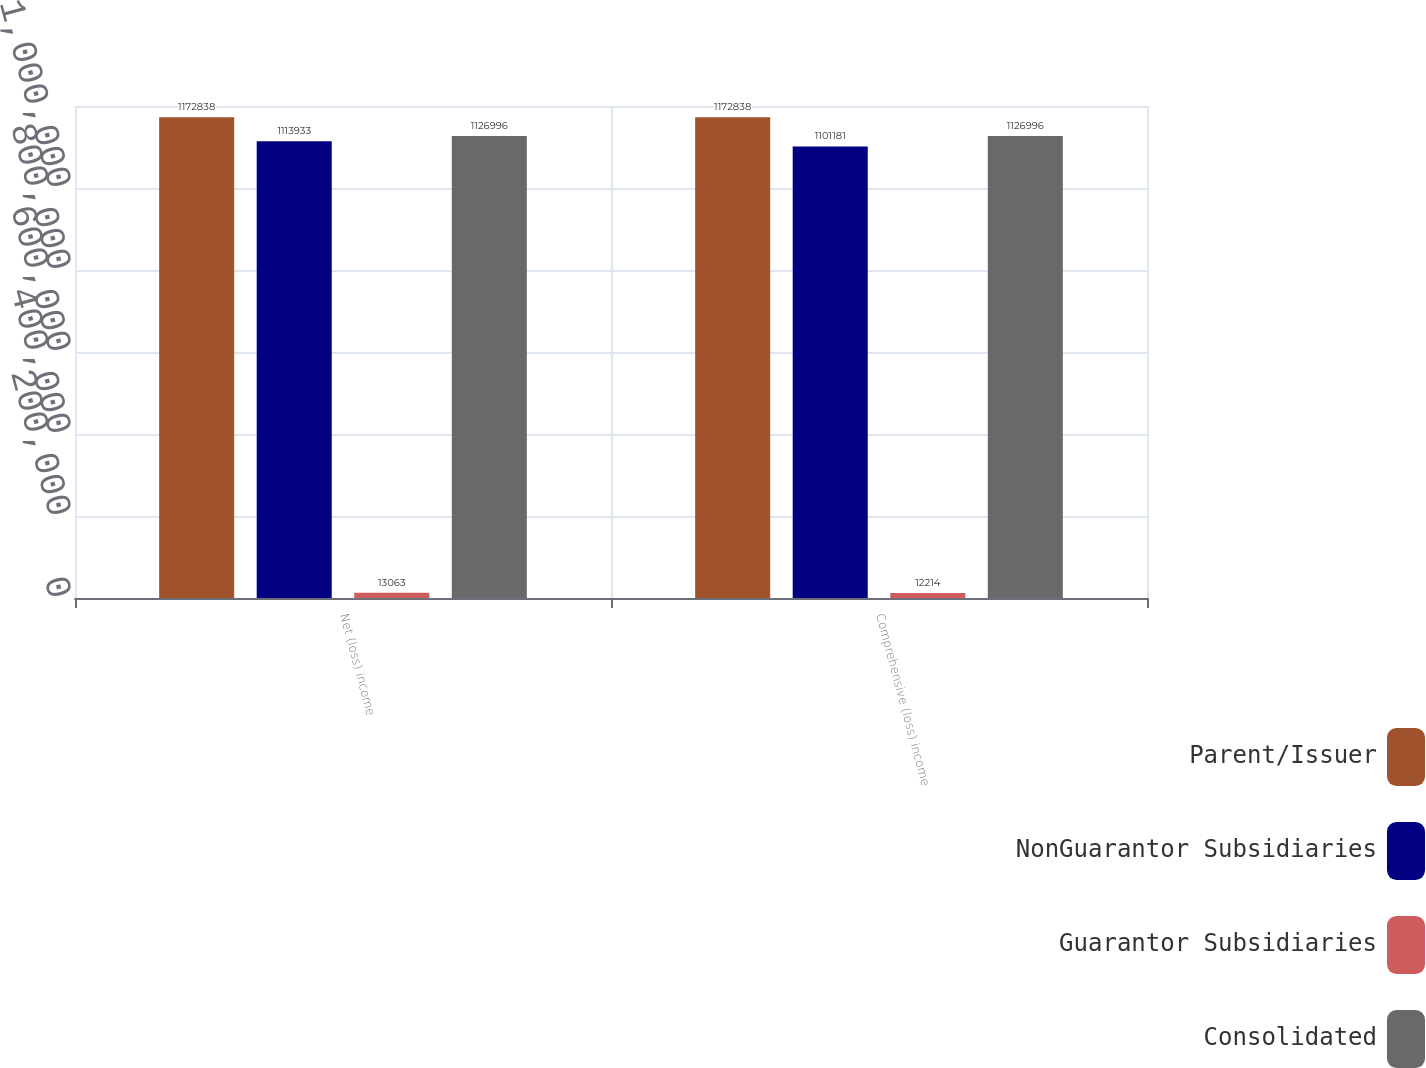<chart> <loc_0><loc_0><loc_500><loc_500><stacked_bar_chart><ecel><fcel>Net (loss) income<fcel>Comprehensive (loss) income<nl><fcel>Parent/Issuer<fcel>1.17284e+06<fcel>1.17284e+06<nl><fcel>NonGuarantor Subsidiaries<fcel>1.11393e+06<fcel>1.10118e+06<nl><fcel>Guarantor Subsidiaries<fcel>13063<fcel>12214<nl><fcel>Consolidated<fcel>1.127e+06<fcel>1.127e+06<nl></chart> 